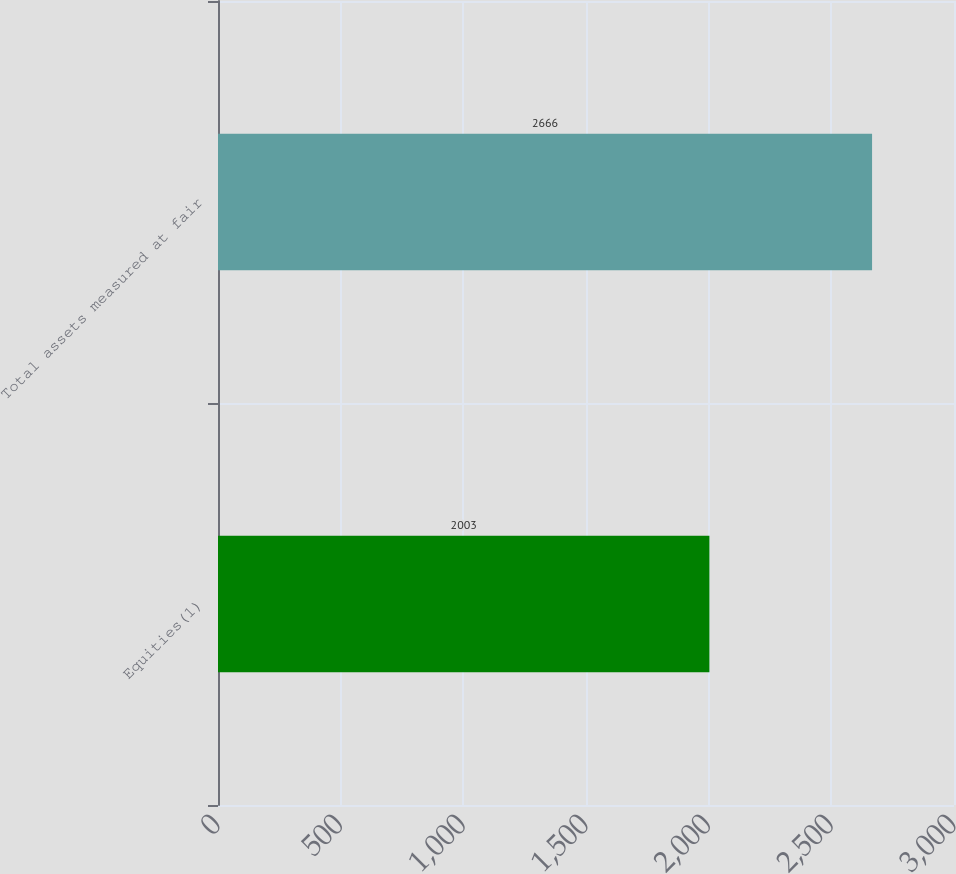Convert chart to OTSL. <chart><loc_0><loc_0><loc_500><loc_500><bar_chart><fcel>Equities(1)<fcel>Total assets measured at fair<nl><fcel>2003<fcel>2666<nl></chart> 